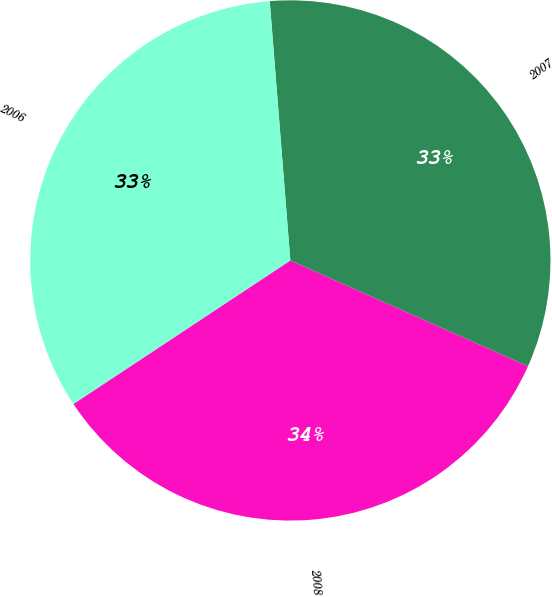Convert chart to OTSL. <chart><loc_0><loc_0><loc_500><loc_500><pie_chart><fcel>2008<fcel>2007<fcel>2006<nl><fcel>34.03%<fcel>32.93%<fcel>33.04%<nl></chart> 